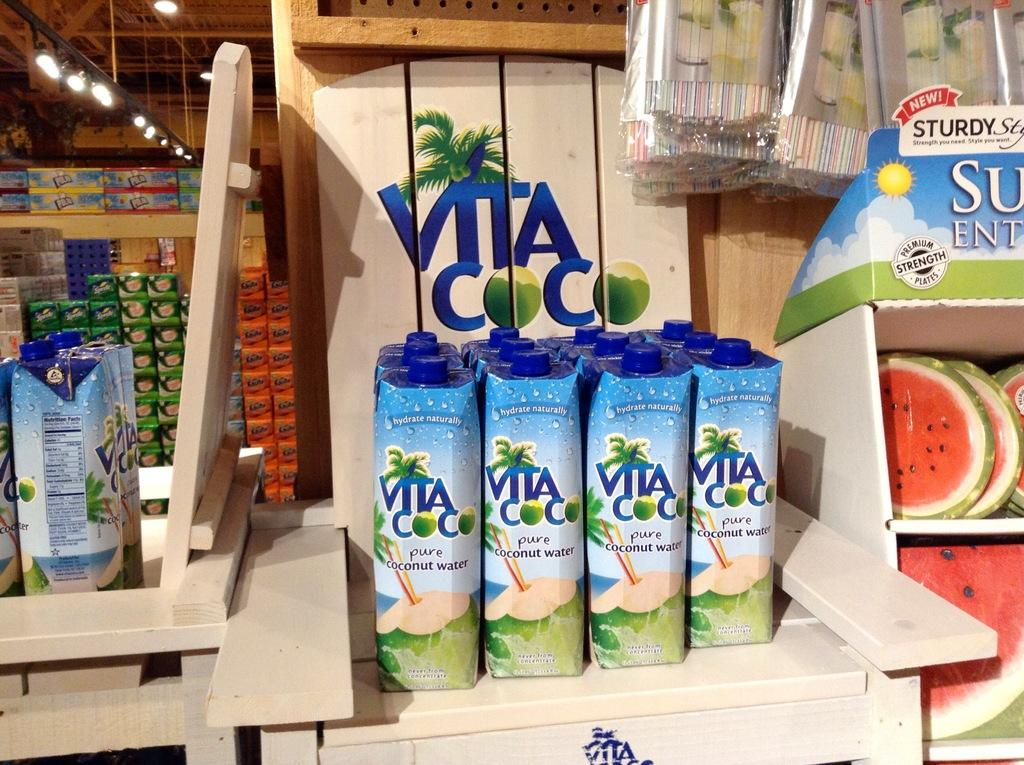<image>
Create a compact narrative representing the image presented. a vita can among many other ones next to it 